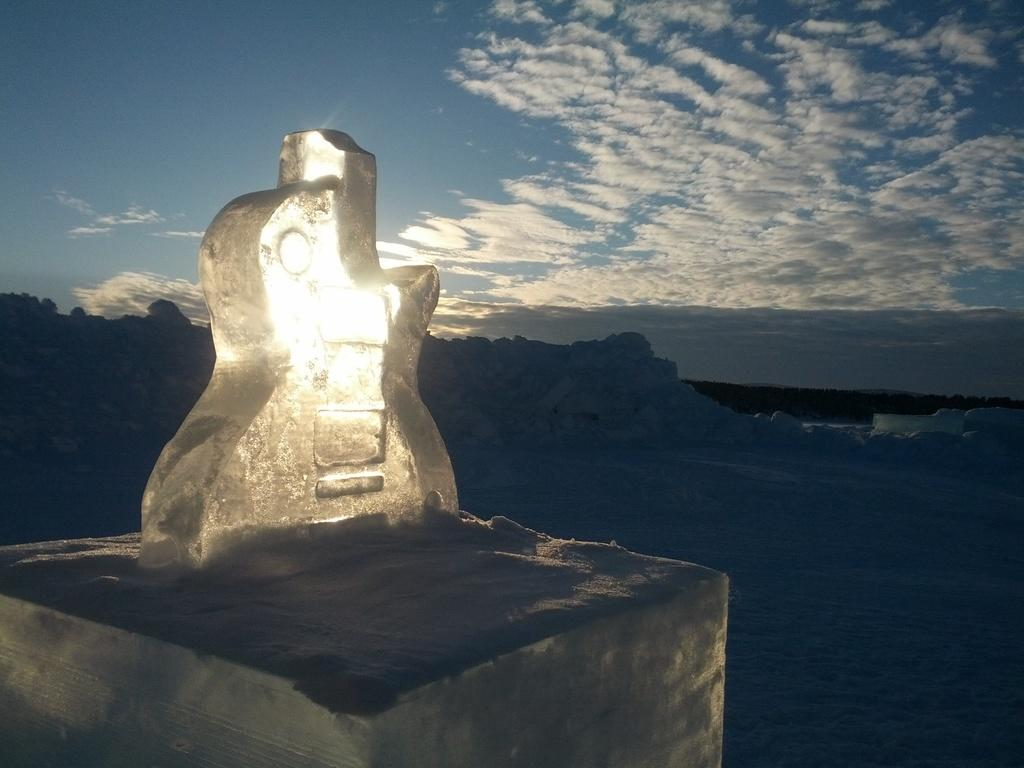What is the main subject in the image? There is a statue in the image. What can be seen in the background of the image? The sky is visible in the background of the image. How would you describe the sky in the image? The sky appears to be cloudy. What type of shock can be seen affecting the statue in the image? There is no shock present in the image; it is a static statue. Is there a coach visible in the image? No, there is no coach present in the image. 